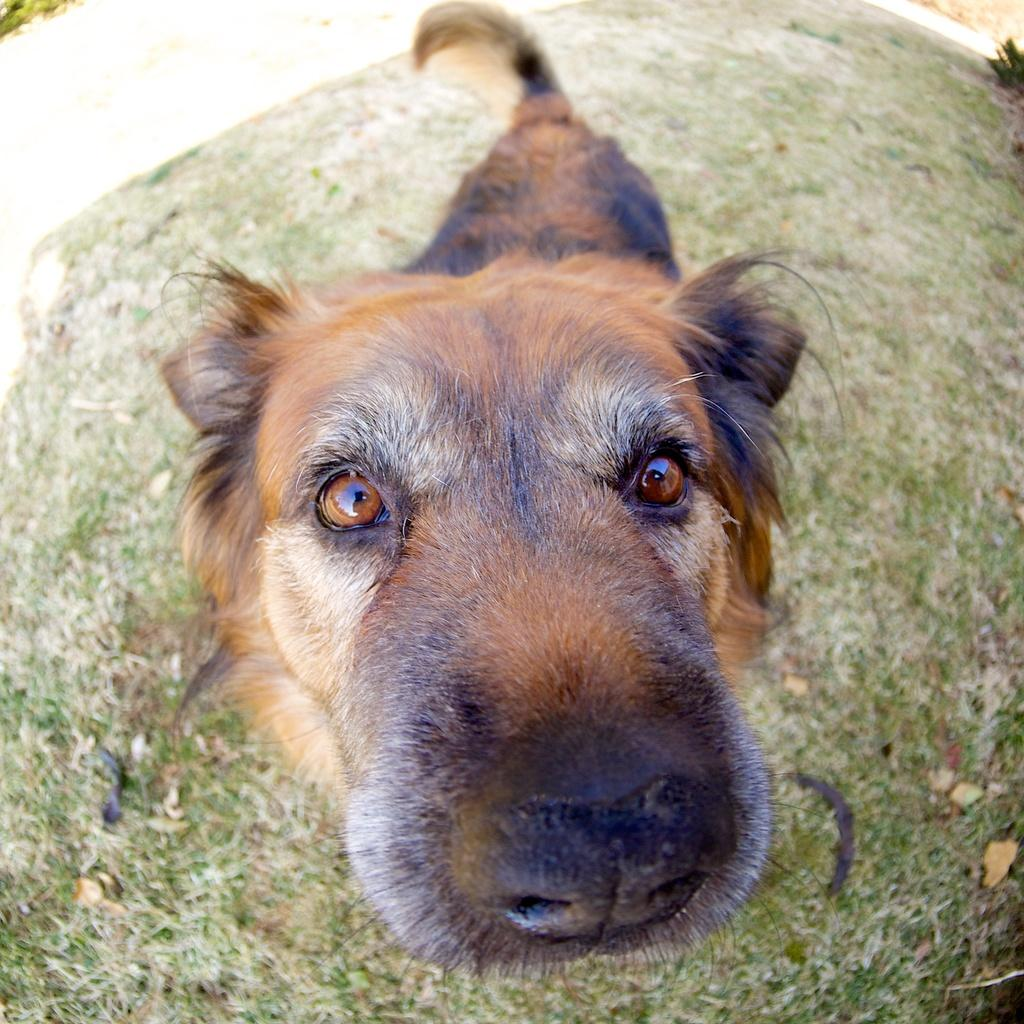What type of animal is present in the image? There is a dog in the image. What can be seen in the background of the image? There is grass in the background of the image. What is the level of peace in the image? The level of peace cannot be determined from the image, as it only shows a dog and grass in the background. 